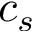<formula> <loc_0><loc_0><loc_500><loc_500>c _ { s }</formula> 